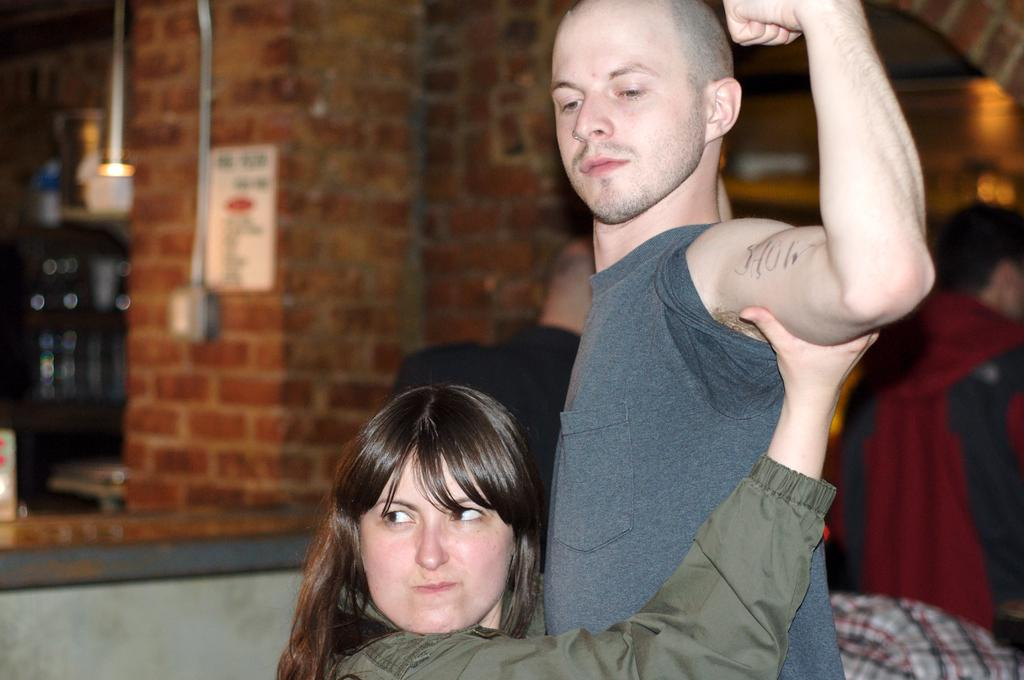How many people are present in the image? There is a man and a woman in the image. What can be seen in the background of the image? There are walls and pipelines attached to the walls in the background of the image. What type of leather is the man wearing in the image? There is no leather visible in the image, as the man's clothing is not described. How many balls are present in the image? There are no balls present in the image. 